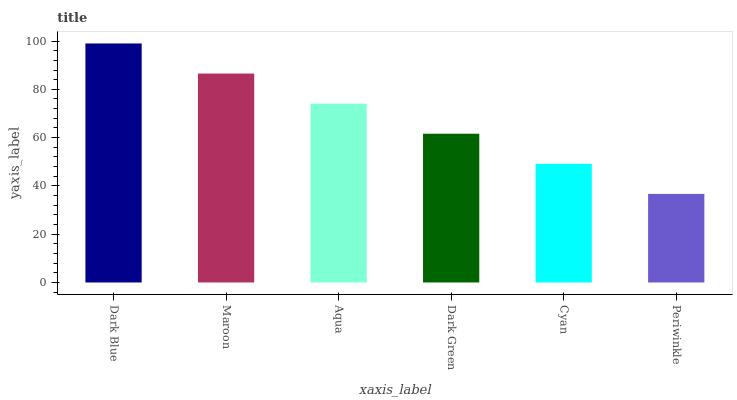Is Periwinkle the minimum?
Answer yes or no. Yes. Is Dark Blue the maximum?
Answer yes or no. Yes. Is Maroon the minimum?
Answer yes or no. No. Is Maroon the maximum?
Answer yes or no. No. Is Dark Blue greater than Maroon?
Answer yes or no. Yes. Is Maroon less than Dark Blue?
Answer yes or no. Yes. Is Maroon greater than Dark Blue?
Answer yes or no. No. Is Dark Blue less than Maroon?
Answer yes or no. No. Is Aqua the high median?
Answer yes or no. Yes. Is Dark Green the low median?
Answer yes or no. Yes. Is Periwinkle the high median?
Answer yes or no. No. Is Aqua the low median?
Answer yes or no. No. 